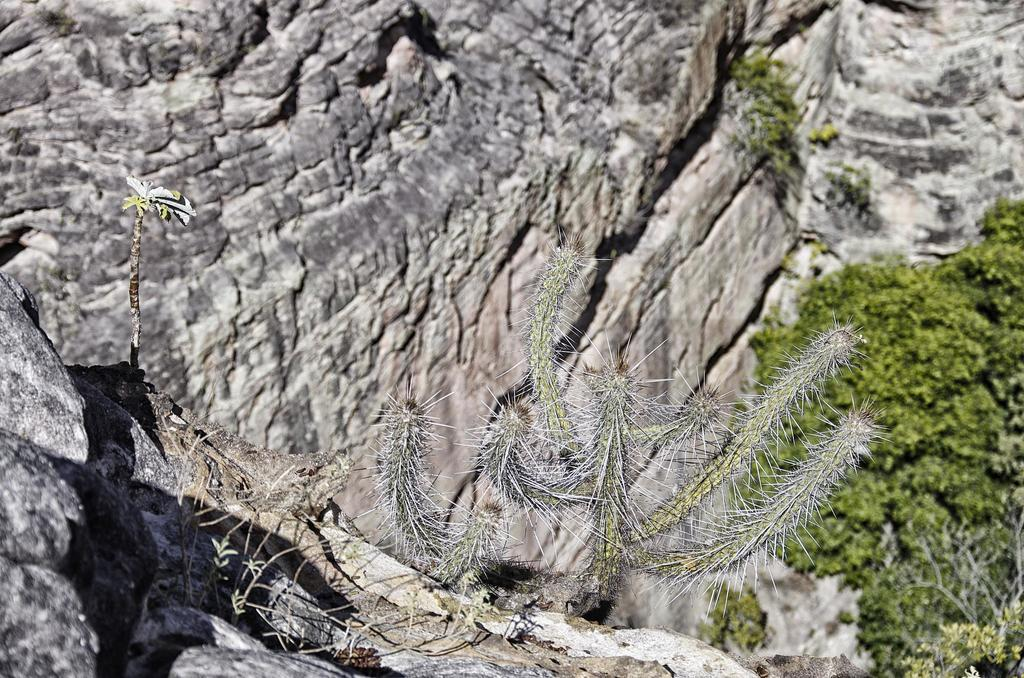What type of natural elements can be seen in the image? There are rocks and trees in the image. Can you describe the rocks in the image? The rocks in the image are likely solid and immovable. What type of vegetation is present in the image? Trees are the type of vegetation present in the image. What type of drug is being used by the person in the image? There is no person present in the image, and therefore no drug use can be observed. 